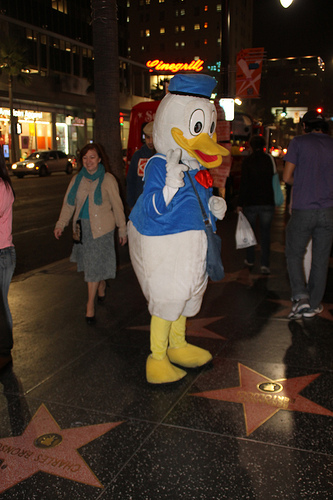<image>
Can you confirm if the duck is next to the star? Yes. The duck is positioned adjacent to the star, located nearby in the same general area. 